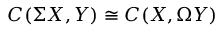<formula> <loc_0><loc_0><loc_500><loc_500>C ( \Sigma X , Y ) \cong C ( X , \Omega Y )</formula> 